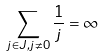<formula> <loc_0><loc_0><loc_500><loc_500>\sum _ { j \in J , j \ne 0 } \frac { 1 } { j } = \infty</formula> 